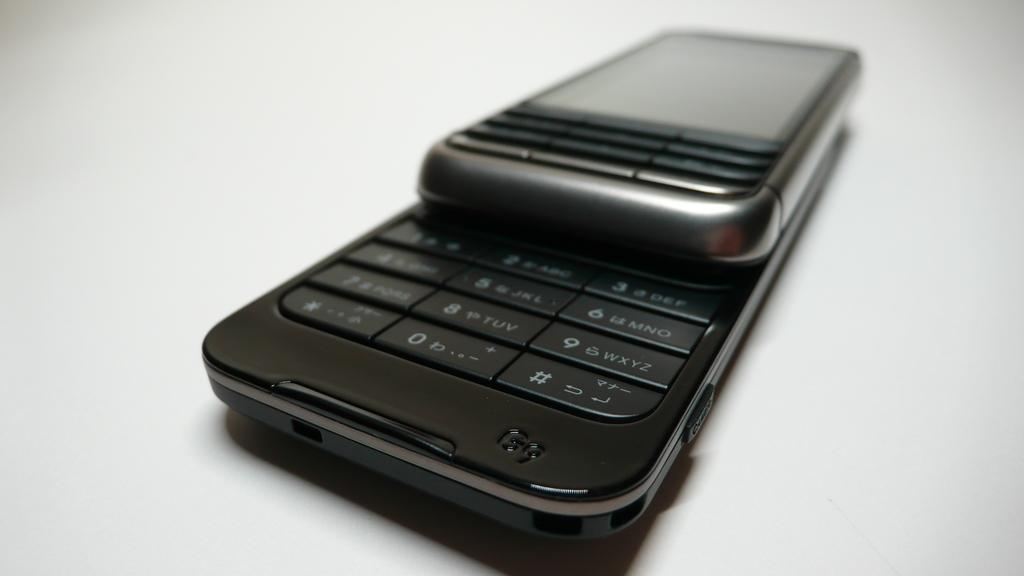<image>
Create a compact narrative representing the image presented. a black and silver, slide cell phone with G9 in the lower corner is laying on a table 